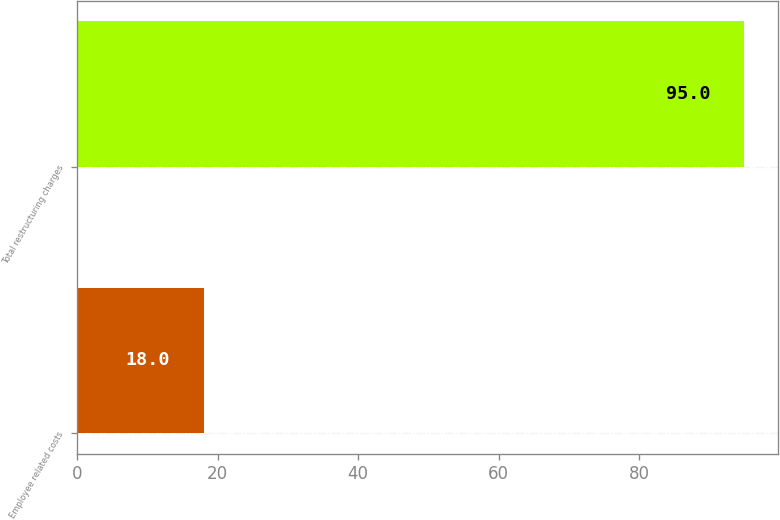Convert chart to OTSL. <chart><loc_0><loc_0><loc_500><loc_500><bar_chart><fcel>Employee related costs<fcel>Total restructuring charges<nl><fcel>18<fcel>95<nl></chart> 